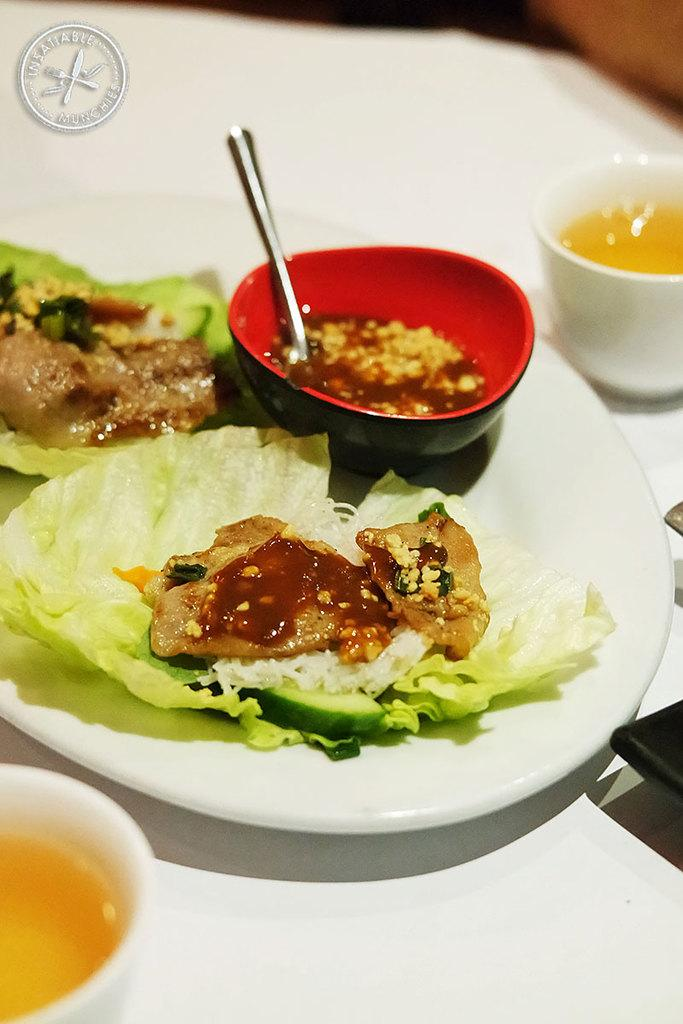What is on the plate that is visible in the image? There is a plate of food in the image. What type of beverage is in the cups in the image? There are two cups with tea in the image. Can you describe any specific markings or symbols in the image? Yes, there is a logo visible in the image. What type of worm can be seen crawling on the plate of food in the image? There is no worm present in the image; it features a plate of food, cups with tea, and a logo. 